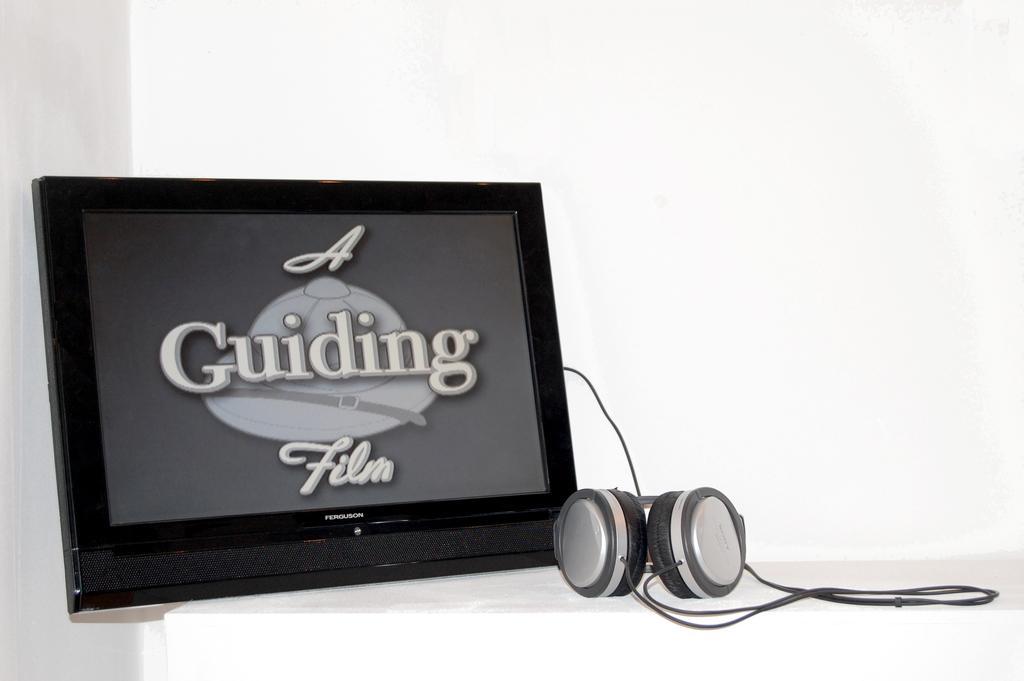Please provide a concise description of this image. This picture shows a television and we see a headset and we see a white background and we see text displaying on the screen. 